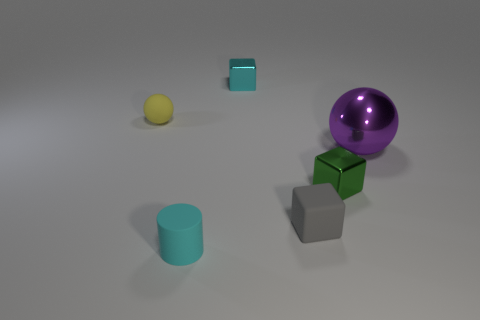There is a purple metallic thing behind the tiny gray object; does it have the same shape as the small thing left of the small cyan matte cylinder?
Offer a terse response. Yes. There is a ball that is right of the tiny cyan object that is in front of the tiny cube that is to the right of the small matte cube; what is its size?
Provide a short and direct response. Large. What size is the cyan thing in front of the large shiny thing?
Provide a short and direct response. Small. There is a cyan object that is in front of the small cyan shiny thing; what is it made of?
Your response must be concise. Rubber. How many yellow things are cylinders or large metallic balls?
Give a very brief answer. 0. Do the gray object and the ball that is on the left side of the purple metallic sphere have the same material?
Offer a very short reply. Yes. Are there the same number of big purple objects in front of the purple shiny object and tiny green shiny objects behind the tiny yellow ball?
Offer a terse response. Yes. There is a gray matte cube; is it the same size as the sphere that is to the right of the cyan matte object?
Provide a succinct answer. No. Is the number of metallic spheres that are in front of the big purple metallic ball greater than the number of matte objects?
Make the answer very short. No. What number of cyan blocks have the same size as the green object?
Offer a terse response. 1. 